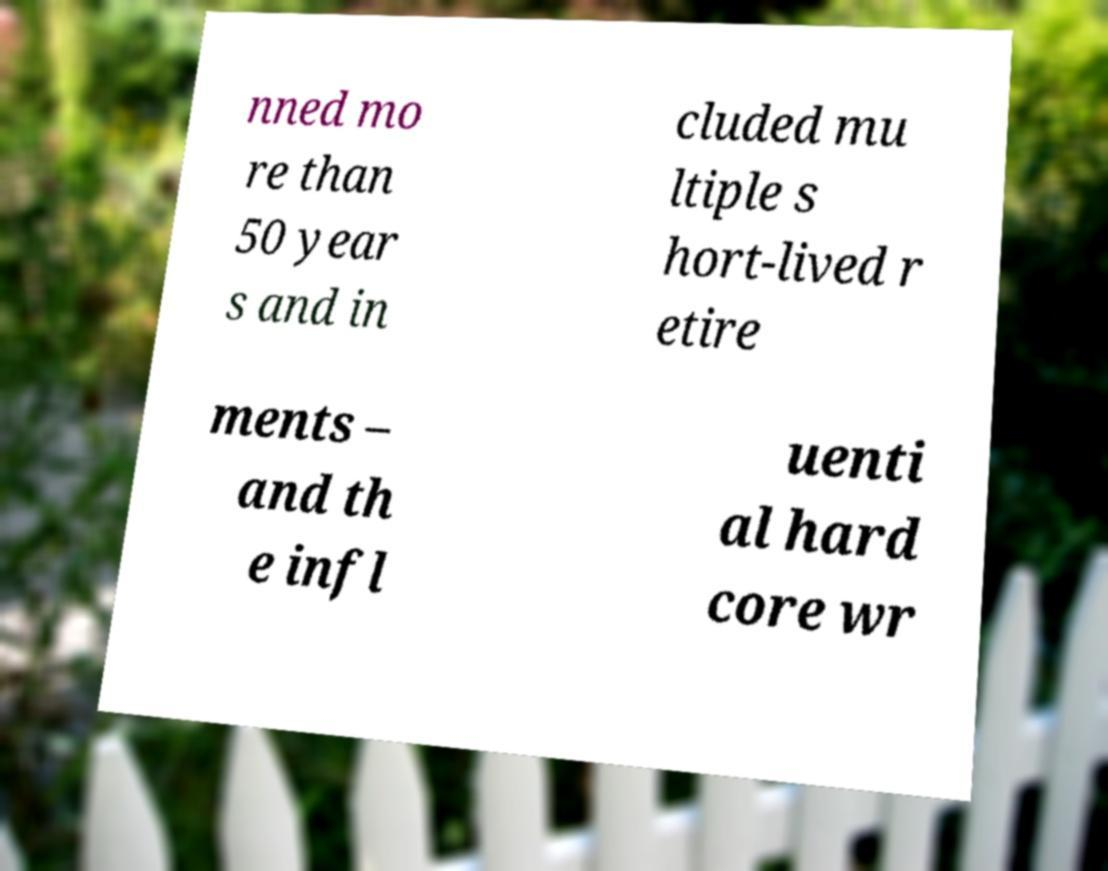Could you extract and type out the text from this image? nned mo re than 50 year s and in cluded mu ltiple s hort-lived r etire ments – and th e infl uenti al hard core wr 